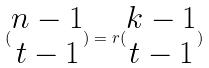Convert formula to latex. <formula><loc_0><loc_0><loc_500><loc_500>( \begin{matrix} n - 1 \\ t - 1 \end{matrix} ) = r ( \begin{matrix} k - 1 \\ t - 1 \end{matrix} )</formula> 